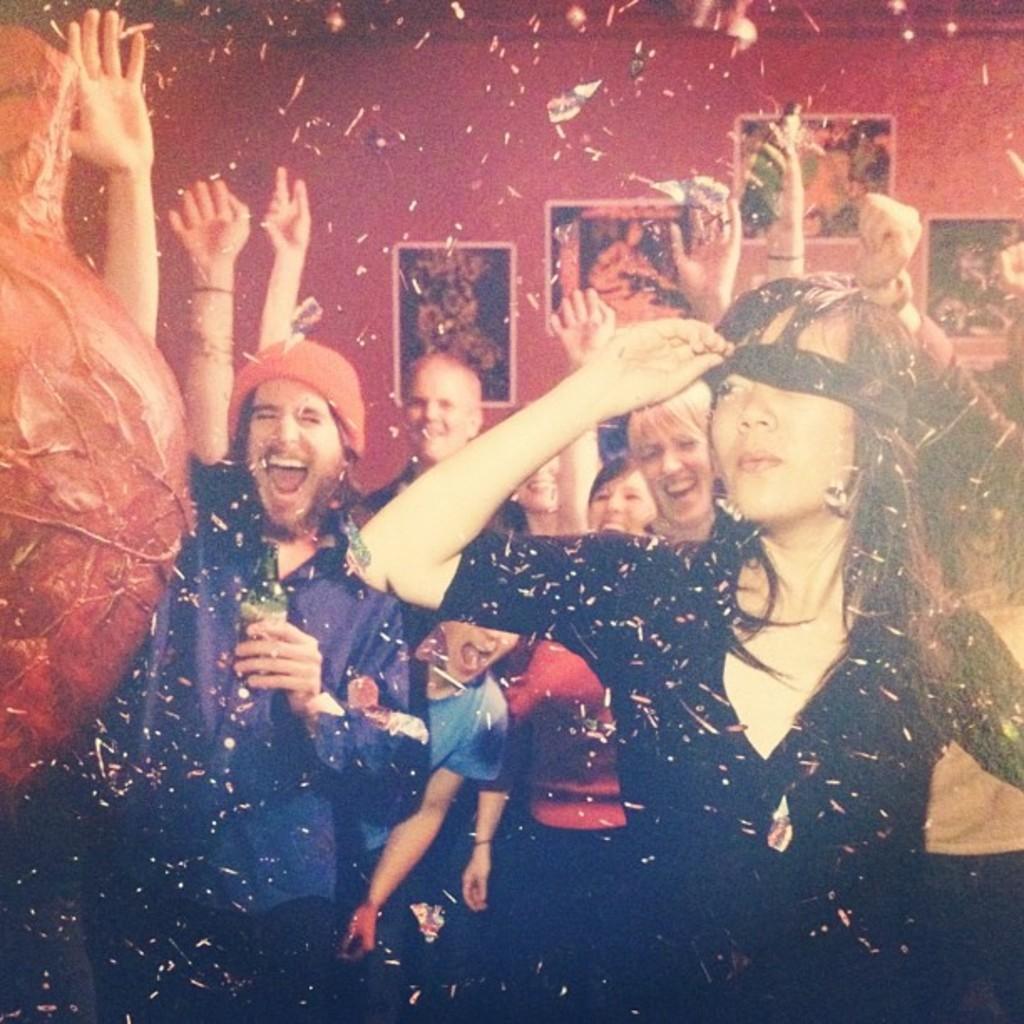Could you give a brief overview of what you see in this image? In this image we can see a few people, one of them is holding a bottle, there are some photo frames on the wall, also we can see some papers. 